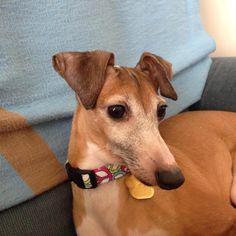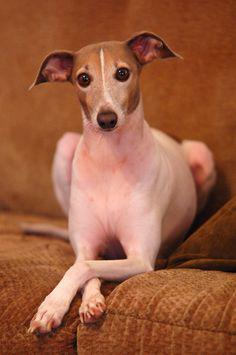The first image is the image on the left, the second image is the image on the right. Evaluate the accuracy of this statement regarding the images: "Each image features a single dog, and one dog looks rightward while the other is facing forward.". Is it true? Answer yes or no. Yes. The first image is the image on the left, the second image is the image on the right. For the images displayed, is the sentence "Two dogs are sitting together on a piece of furniture in the image on the left." factually correct? Answer yes or no. No. 